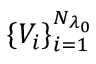<formula> <loc_0><loc_0><loc_500><loc_500>\{ V _ { i } \} _ { i = 1 } ^ { N _ { \lambda _ { 0 } } }</formula> 